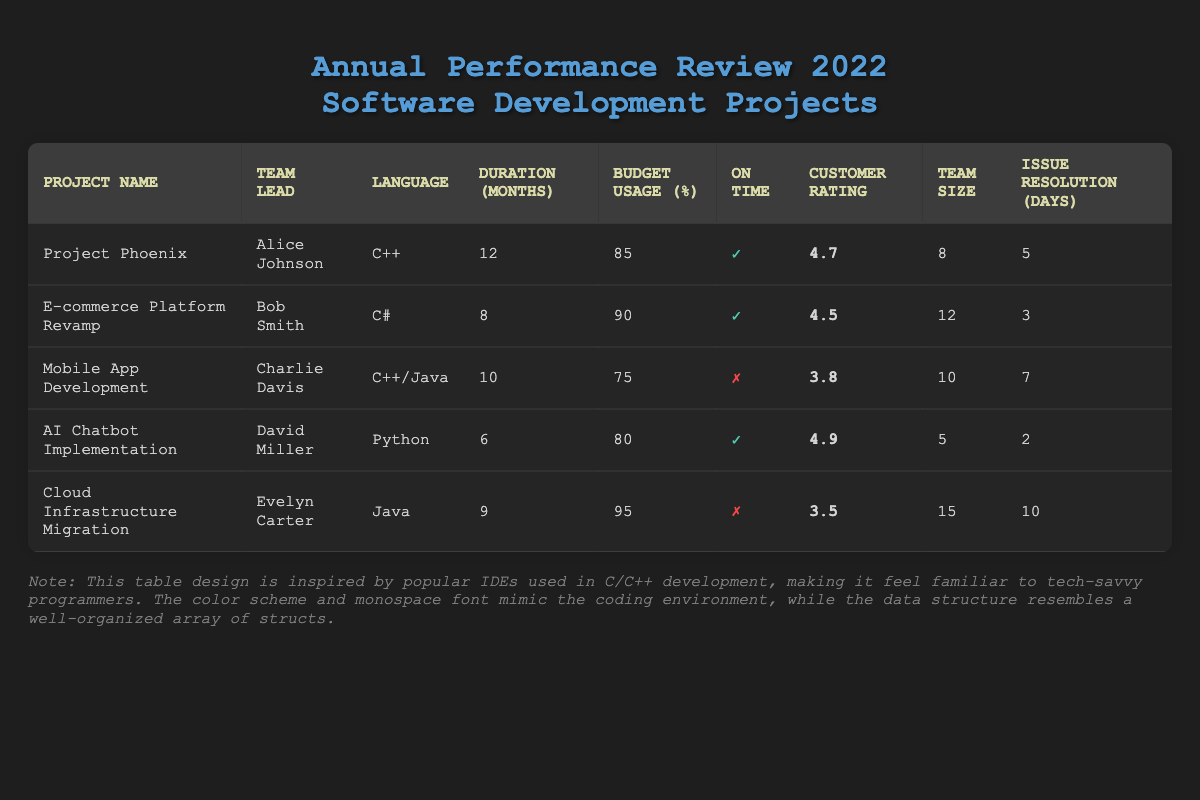What is the team lead for the 'Mobile App Development' project? You can find the team lead by looking under the 'Team Lead' column in the row corresponding to 'Mobile App Development'. The name listed is Charlie Davis.
Answer: Charlie Davis Which project had the highest customer satisfaction rating? By checking the 'Customer Rating' column and identifying the highest value, you see that 'AI Chatbot Implementation' has a rating of 4.9, which is the highest among all projects.
Answer: AI Chatbot Implementation How many projects were delivered on time? Review the 'On Time' column and count the number of projects marked with a check (✓). There are four projects: 'Project Phoenix', 'E-commerce Platform Revamp', 'AI Chatbot Implementation', and one project had an "On Time" status of not delivered.
Answer: 4 What is the average budget usage percentage for all projects? To find the average, sum the budget usage percentages: (85 + 90 + 75 + 80 + 95) = 425. Then divide by the number of projects (5): 425 / 5 = 85.
Answer: 85 Is 'Cloud Infrastructure Migration' delivered on time? Looking at the 'On Time' column for 'Cloud Infrastructure Migration', it is marked with an "X" (✗), indicating it was not delivered on time.
Answer: No What is the team size difference between 'AI Chatbot Implementation' and 'Cloud Infrastructure Migration'? Find the team size for both projects from the 'Team Size' column: 'AI Chatbot Implementation' has a size of 5, and 'Cloud Infrastructure Migration' has 15. Calculate the difference: 15 - 5 = 10.
Answer: 10 Which development languages were used in projects with a customer satisfaction rating above 4.5? First, look for projects with a rating above 4.5. This includes 'AI Chatbot Implementation' (4.9) and 'Project Phoenix' (4.7). The corresponding development languages are Python and C++.
Answer: Python, C++ What is the minimum issue resolution time recorded among all projects? Check the 'Issue Resolution (Days)' column for the lowest value by scanning each row. The minimum value is 2 days, which belongs to 'AI Chatbot Implementation'.
Answer: 2 